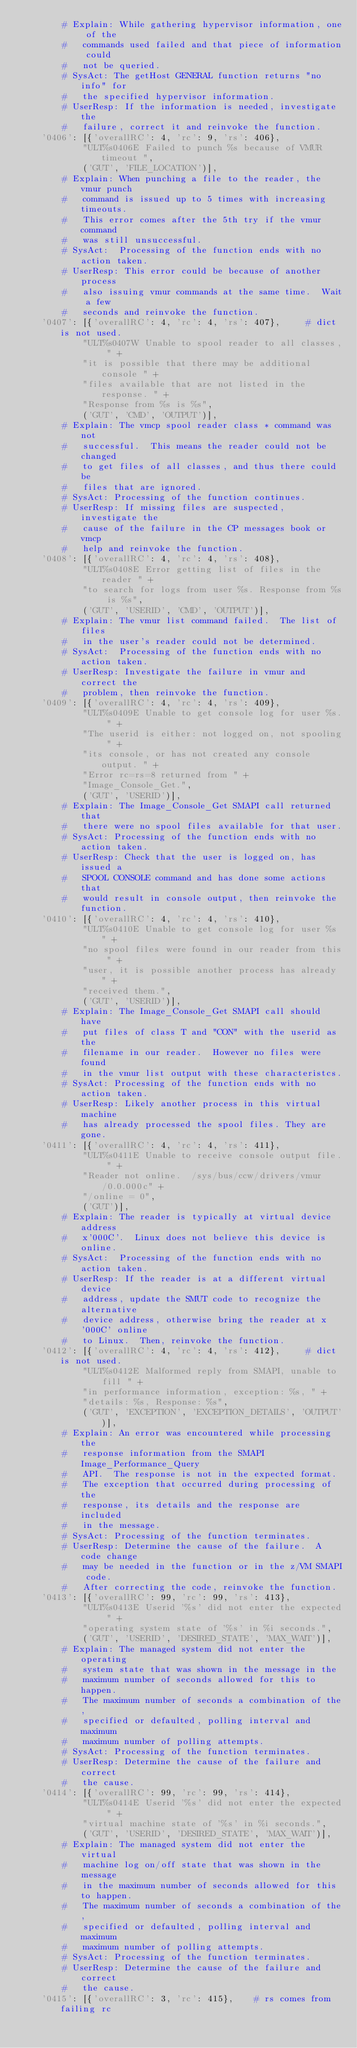Convert code to text. <code><loc_0><loc_0><loc_500><loc_500><_Python_>        # Explain: While gathering hypervisor information, one of the
        #   commands used failed and that piece of information could
        #   not be queried.
        # SysAct: The getHost GENERAL function returns "no info" for
        #   the specified hypervisor information.
        # UserResp: If the information is needed, investigate the
        #   failure, correct it and reinvoke the function.
    '0406': [{'overallRC': 4, 'rc': 9, 'rs': 406},
            "ULT%s0406E Failed to punch %s because of VMUR timeout ",
            ('GUT', 'FILE_LOCATION')],
        # Explain: When punching a file to the reader, the vmur punch
        #   command is issued up to 5 times with increasing timeouts.
        #   This error comes after the 5th try if the vmur command
        #   was still unsuccessful.
        # SysAct:  Processing of the function ends with no action taken.
        # UserResp: This error could be because of another process
        #   also issuing vmur commands at the same time.  Wait a few
        #   seconds and reinvoke the function.
    '0407': [{'overallRC': 4, 'rc': 4, 'rs': 407},     # dict is not used.
            "ULT%s0407W Unable to spool reader to all classes, " +
            "it is possible that there may be additional console " +
            "files available that are not listed in the response. " +
            "Response from %s is %s",
            ('GUT', 'CMD', 'OUTPUT')],
        # Explain: The vmcp spool reader class * command was not
        #   successful.  This means the reader could not be changed
        #   to get files of all classes, and thus there could be
        #   files that are ignored.
        # SysAct: Processing of the function continues.
        # UserResp: If missing files are suspected, investigate the
        #   cause of the failure in the CP messages book or vmcp
        #   help and reinvoke the function.
    '0408': [{'overallRC': 4, 'rc': 4, 'rs': 408},
            "ULT%s0408E Error getting list of files in the reader " +
            "to search for logs from user %s. Response from %s is %s",
            ('GUT', 'USERID', 'CMD', 'OUTPUT')],
        # Explain: The vmur list command failed.  The list of files
        #   in the user's reader could not be determined.
        # SysAct:  Processing of the function ends with no action taken.
        # UserResp: Investigate the failure in vmur and correct the
        #   problem, then reinvoke the function.
    '0409': [{'overallRC': 4, 'rc': 4, 'rs': 409},
            "ULT%s0409E Unable to get console log for user %s. " +
            "The userid is either: not logged on, not spooling " +
            "its console, or has not created any console output. " +
            "Error rc=rs=8 returned from " +
            "Image_Console_Get.",
            ('GUT', 'USERID')],
        # Explain: The Image_Console_Get SMAPI call returned that
        #   there were no spool files available for that user.
        # SysAct: Processing of the function ends with no action taken.
        # UserResp: Check that the user is logged on, has issued a
        #   SPOOL CONSOLE command and has done some actions that
        #   would result in console output, then reinvoke the function.
    '0410': [{'overallRC': 4, 'rc': 4, 'rs': 410},
            "ULT%s0410E Unable to get console log for user %s " +
            "no spool files were found in our reader from this " +
            "user, it is possible another process has already " +
            "received them.",
            ('GUT', 'USERID')],
        # Explain: The Image_Console_Get SMAPI call should have
        #   put files of class T and "CON" with the userid as the
        #   filename in our reader.  However no files were found
        #   in the vmur list output with these characteristcs.
        # SysAct: Processing of the function ends with no action taken.
        # UserResp: Likely another process in this virtual machine
        #   has already processed the spool files. They are gone.
    '0411': [{'overallRC': 4, 'rc': 4, 'rs': 411},
            "ULT%s0411E Unable to receive console output file. " +
            "Reader not online.  /sys/bus/ccw/drivers/vmur/0.0.000c" +
            "/online = 0",
            ('GUT')],
        # Explain: The reader is typically at virtual device address
        #   x'000C'.  Linux does not believe this device is online.
        # SysAct:  Processing of the function ends with no action taken.
        # UserResp: If the reader is at a different virtual device
        #   address, update the SMUT code to recognize the alternative
        #   device address, otherwise bring the reader at x'000C' online
        #   to Linux.  Then, reinvoke the function.
    '0412': [{'overallRC': 4, 'rc': 4, 'rs': 412},     # dict is not used.
            "ULT%s0412E Malformed reply from SMAPI, unable to fill " +
            "in performance information, exception: %s, " +
            "details: %s, Response: %s",
            ('GUT', 'EXCEPTION', 'EXCEPTION_DETAILS', 'OUTPUT')],
        # Explain: An error was encountered while processing the
        #   response information from the SMAPI Image_Performance_Query
        #   API.  The response is not in the expected format.
        #   The exception that occurred during processing of the
        #   response, its details and the response are included
        #   in the message.
        # SysAct: Processing of the function terminates.
        # UserResp: Determine the cause of the failure.  A code change
        #   may be needed in the function or in the z/VM SMAPI code.
        #   After correcting the code, reinvoke the function.
    '0413': [{'overallRC': 99, 'rc': 99, 'rs': 413},
            "ULT%s0413E Userid '%s' did not enter the expected " +
            "operating system state of '%s' in %i seconds.",
            ('GUT', 'USERID', 'DESIRED_STATE', 'MAX_WAIT')],
        # Explain: The managed system did not enter the operating
        #   system state that was shown in the message in the
        #   maximum number of seconds allowed for this to happen.
        #   The maximum number of seconds a combination of the,
        #   specified or defaulted, polling interval and maximum
        #   maximum number of polling attempts.
        # SysAct: Processing of the function terminates.
        # UserResp: Determine the cause of the failure and correct
        #   the cause.
    '0414': [{'overallRC': 99, 'rc': 99, 'rs': 414},
            "ULT%s0414E Userid '%s' did not enter the expected " +
            "virtual machine state of '%s' in %i seconds.",
            ('GUT', 'USERID', 'DESIRED_STATE', 'MAX_WAIT')],
        # Explain: The managed system did not enter the virtual
        #   machine log on/off state that was shown in the message
        #   in the maximum number of seconds allowed for this to happen.
        #   The maximum number of seconds a combination of the,
        #   specified or defaulted, polling interval and maximum
        #   maximum number of polling attempts.
        # SysAct: Processing of the function terminates.
        # UserResp: Determine the cause of the failure and correct
        #   the cause.
    '0415': [{'overallRC': 3, 'rc': 415},    # rs comes from failing rc</code> 